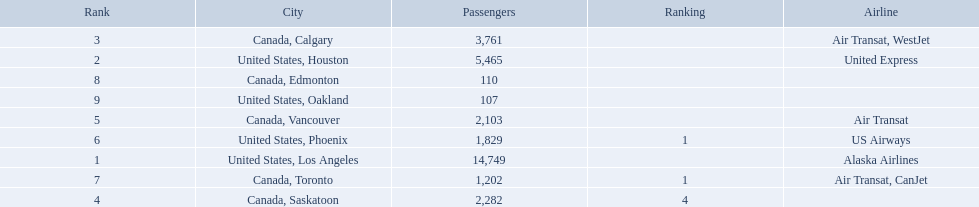What numbers are in the passengers column? 14,749, 5,465, 3,761, 2,282, 2,103, 1,829, 1,202, 110, 107. Can you parse all the data within this table? {'header': ['Rank', 'City', 'Passengers', 'Ranking', 'Airline'], 'rows': [['3', 'Canada, Calgary', '3,761', '', 'Air Transat, WestJet'], ['2', 'United States, Houston', '5,465', '', 'United Express'], ['8', 'Canada, Edmonton', '110', '', ''], ['9', 'United States, Oakland', '107', '', ''], ['5', 'Canada, Vancouver', '2,103', '', 'Air Transat'], ['6', 'United States, Phoenix', '1,829', '1', 'US Airways'], ['1', 'United States, Los Angeles', '14,749', '', 'Alaska Airlines'], ['7', 'Canada, Toronto', '1,202', '1', 'Air Transat, CanJet'], ['4', 'Canada, Saskatoon', '2,282', '4', '']]} Which number is the lowest number in the passengers column? 107. What city is associated with this number? United States, Oakland. 